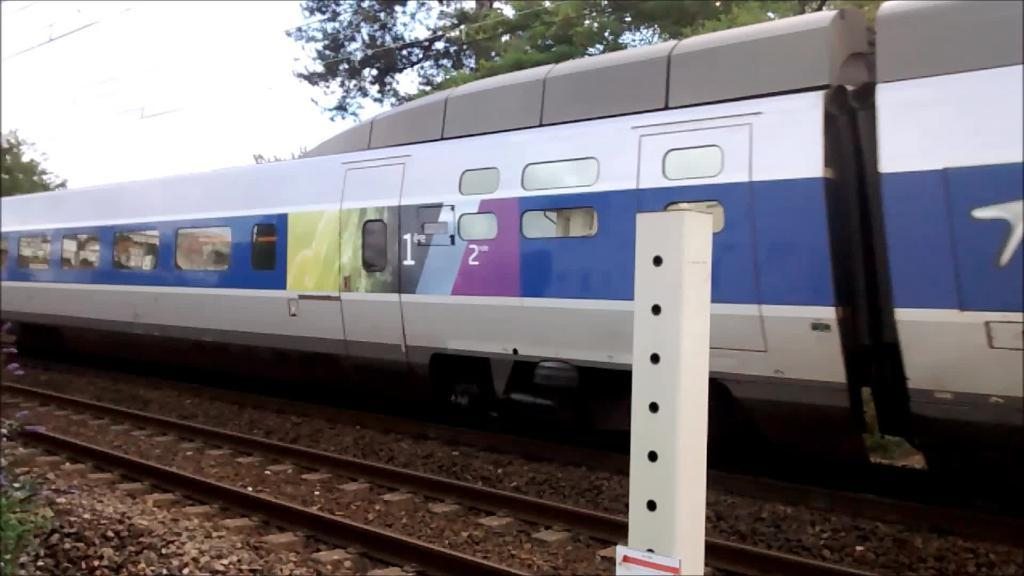What is the main subject of the image? The main subject of the image is a train. Where is the train located in the image? The train is on a track. What can be seen in the background of the image? There are trees and sky visible in the background of the image. What is the pole at the bottom of the image used for? The purpose of the pole is not specified in the image. How many boys are playing with the pigs in the image? There are no boys or pigs present in the image; it features a train on a track with trees and sky in the background. 